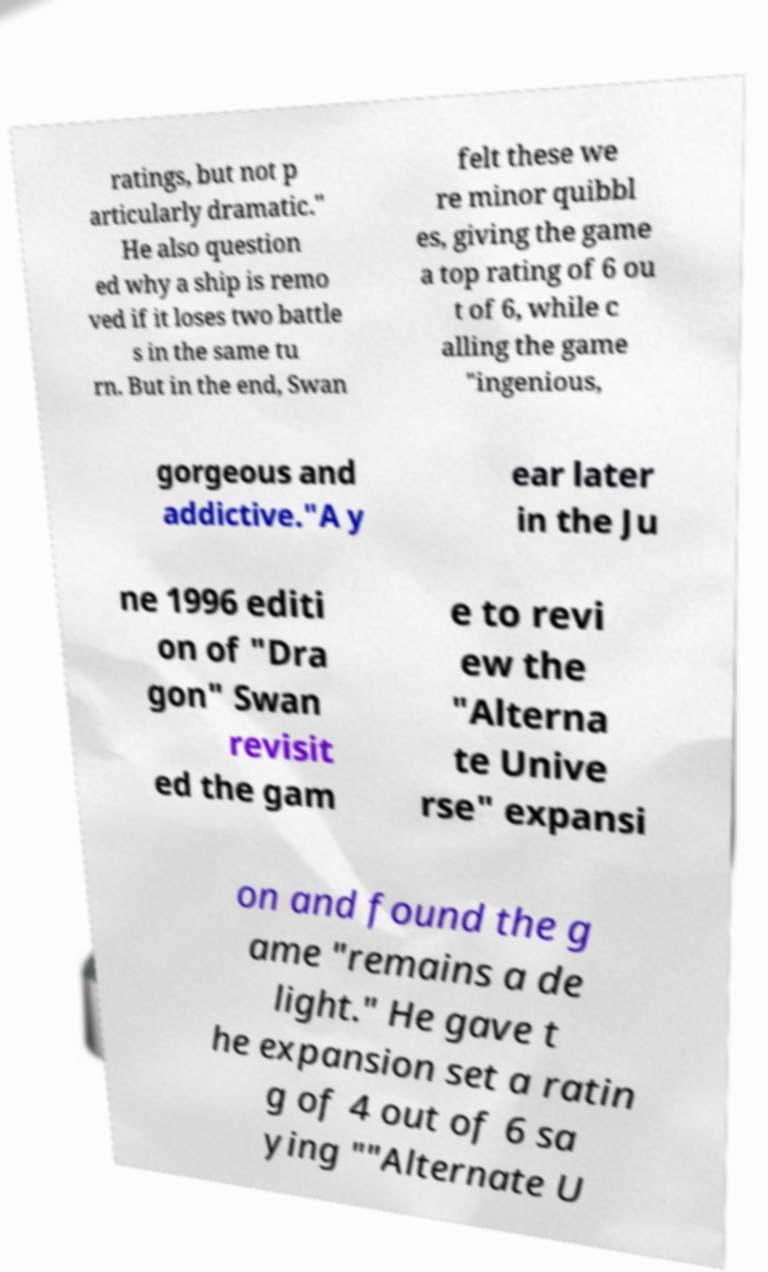Could you assist in decoding the text presented in this image and type it out clearly? ratings, but not p articularly dramatic." He also question ed why a ship is remo ved if it loses two battle s in the same tu rn. But in the end, Swan felt these we re minor quibbl es, giving the game a top rating of 6 ou t of 6, while c alling the game "ingenious, gorgeous and addictive."A y ear later in the Ju ne 1996 editi on of "Dra gon" Swan revisit ed the gam e to revi ew the "Alterna te Unive rse" expansi on and found the g ame "remains a de light." He gave t he expansion set a ratin g of 4 out of 6 sa ying ""Alternate U 